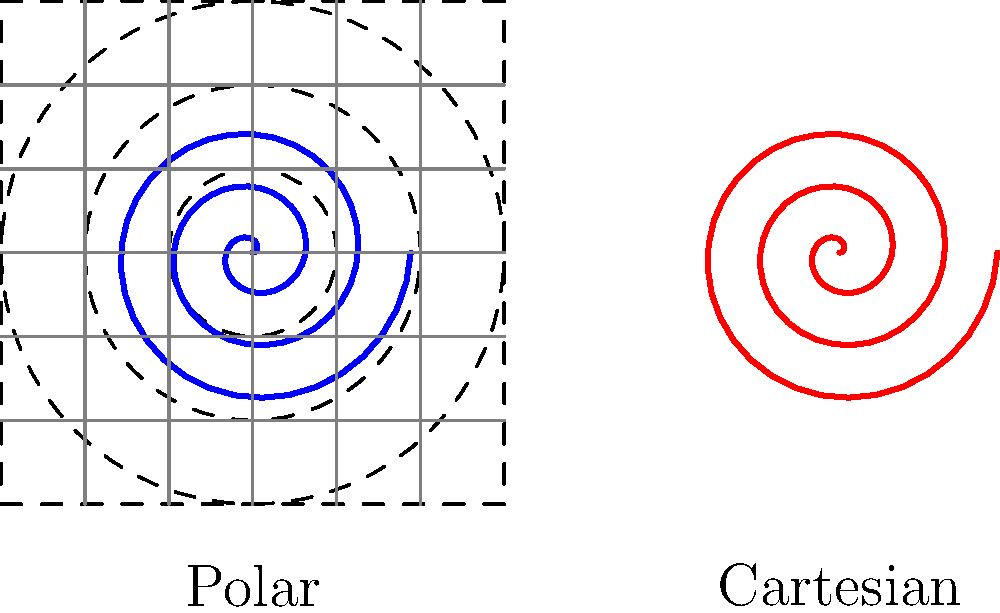Consider the modeling of spiral galaxies using both polar and Cartesian coordinate systems, as illustrated in the figure. Which coordinate system provides a more concise and computationally efficient representation for describing the spiral structure, and why? To answer this question, we need to consider the mathematical representations of spiral galaxies in both coordinate systems:

1. Polar coordinates:
   In polar coordinates, a spiral galaxy can be described by the equation:
   $$r = a\theta$$
   where $r$ is the radial distance, $\theta$ is the angle, and $a$ is a constant determining the tightness of the spiral.

2. Cartesian coordinates:
   The same spiral in Cartesian coordinates would be described by the parametric equations:
   $$x = a\theta \cos(\theta)$$
   $$y = a\theta \sin(\theta)$$

Now, let's compare the two representations:

a) Simplicity: The polar coordinate equation is simpler, requiring only one equation instead of two.

b) Computational efficiency: Calculating points along the spiral in polar coordinates requires fewer operations than in Cartesian coordinates, which involve trigonometric functions for each point.

c) Natural fit: Spiral galaxies inherently have a radial structure, which aligns more naturally with polar coordinates.

d) Data analysis: Many properties of spiral galaxies (e.g., rotation curves, density waves) are more easily studied in polar coordinates.

e) Symmetry: Polar coordinates better capture the rotational symmetry of spiral galaxies.

While both coordinate systems can represent spiral galaxies, the polar coordinate system offers a more concise mathematical description and aligns better with the physical structure of these astronomical objects. This leads to computational advantages in modeling and analyzing spiral galaxies.
Answer: Polar coordinates are more efficient for modeling spiral galaxies due to simpler equations, fewer computations, and better alignment with galactic structure. 